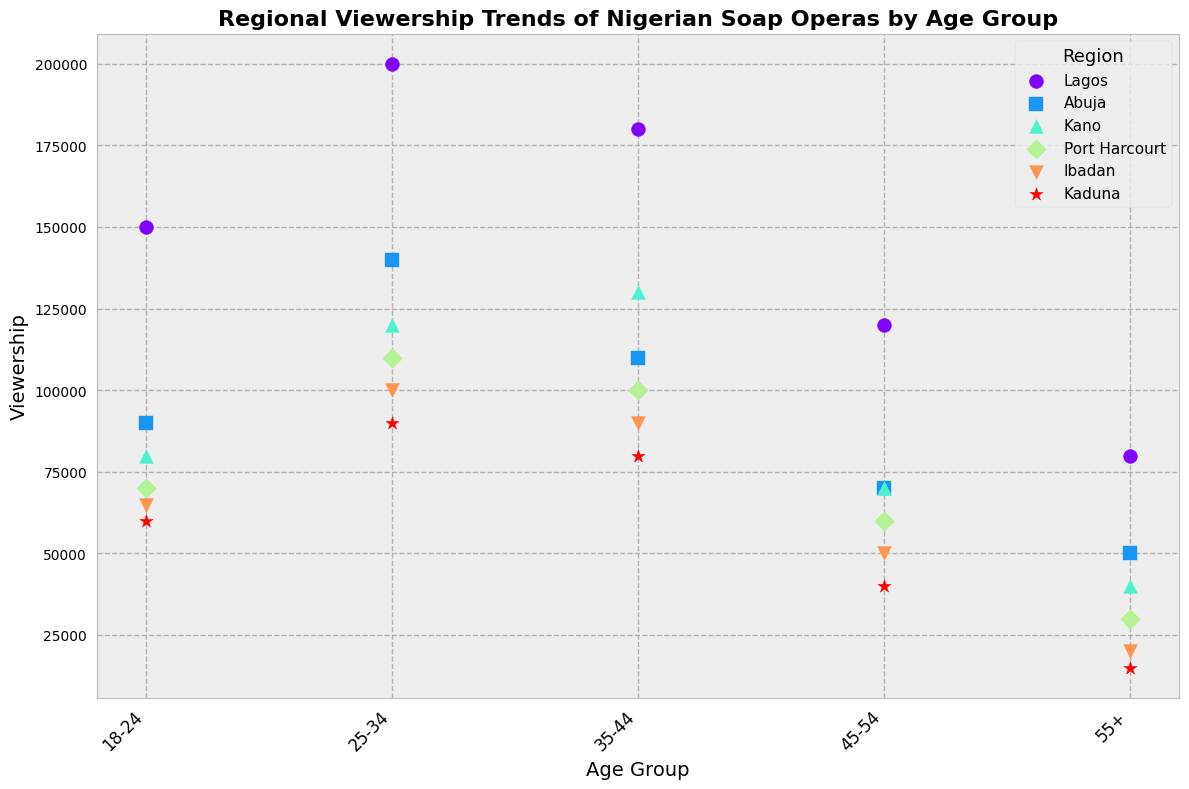What region has the highest viewership in the 25-34 age group? Look at the scatter plot for the 25-34 age group and identify the highest point. The highest point in this age group corresponds to Lagos.
Answer: Lagos Which age group in Abuja has the lowest viewership? Find the lowest point among the scattered points for Abuja. The 55+ age group has the lowest viewership.
Answer: 55+ Is the viewership of the 18-24 age group greater in Lagos or Abuja? Compare the points on the scatter plot for 18-24 age group between Lagos and Abuja. The point for Lagos is higher in the 18-24 age group than Abuja.
Answer: Lagos Which region has the greatest difference in viewership between the 25-34 and 55+ age groups? Look for the difference in height of the plots between the 25-34 and 55+ age groups across all regions. The largest difference is in Lagos.
Answer: Lagos Is the viewership trend increasing or decreasing with age in Port Harcourt? Observe the trend of the scattered points for Port Harcourt across the age groups from 18-24 to 55+. The trend is decreasing.
Answer: Decreasing What is the total viewership for the 35-44 age group across all regions? Sum the y-values of the points that correspond to the 35-44 age group across all regions: 180000 (Lagos) + 110000 (Abuja) + 130000 (Kano) + 100000 (Port Harcourt) + 90000 (Ibadan) + 80000 (Kaduna). The total is 690,000.
Answer: 690,000 In which age group does Kano have higher viewership than Ibadan? Compare the points for Kano and Ibadan within each age group. Kano has higher viewership than Ibadan in all age groups except 18-24.
Answer: 25-34, 35-44, 45-54, 55+ What is the percentage difference in viewership of the 18-24 age group between Lagos and Port Harcourt? Calculate the difference and then find the percentage relative to Port Harcourt. Difference = 150000 - 70000 = 80000. Percentage difference = (80000 / 70000) * 100 = 114.29%
Answer: 114.29% How does the viewership of the 55+ age group in Kano compare to that in Lagos? Compare the points on the scatter plot for the 55+ age group between Kano and Lagos. Kano has lower viewership (40,000) compared to Lagos (80,000).
Answer: Lower Which region has the most consistent viewership across all age groups? Look for the region with the flattest trend line across the scatter points. Abuja has the most consistent viewership across all age groups.
Answer: Abuja 